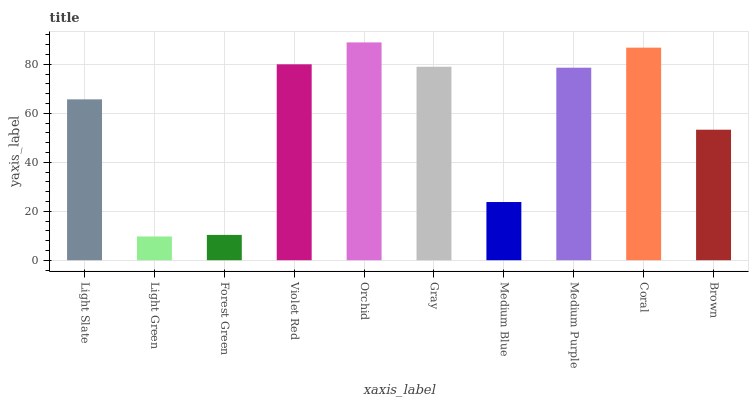Is Light Green the minimum?
Answer yes or no. Yes. Is Orchid the maximum?
Answer yes or no. Yes. Is Forest Green the minimum?
Answer yes or no. No. Is Forest Green the maximum?
Answer yes or no. No. Is Forest Green greater than Light Green?
Answer yes or no. Yes. Is Light Green less than Forest Green?
Answer yes or no. Yes. Is Light Green greater than Forest Green?
Answer yes or no. No. Is Forest Green less than Light Green?
Answer yes or no. No. Is Medium Purple the high median?
Answer yes or no. Yes. Is Light Slate the low median?
Answer yes or no. Yes. Is Brown the high median?
Answer yes or no. No. Is Medium Blue the low median?
Answer yes or no. No. 